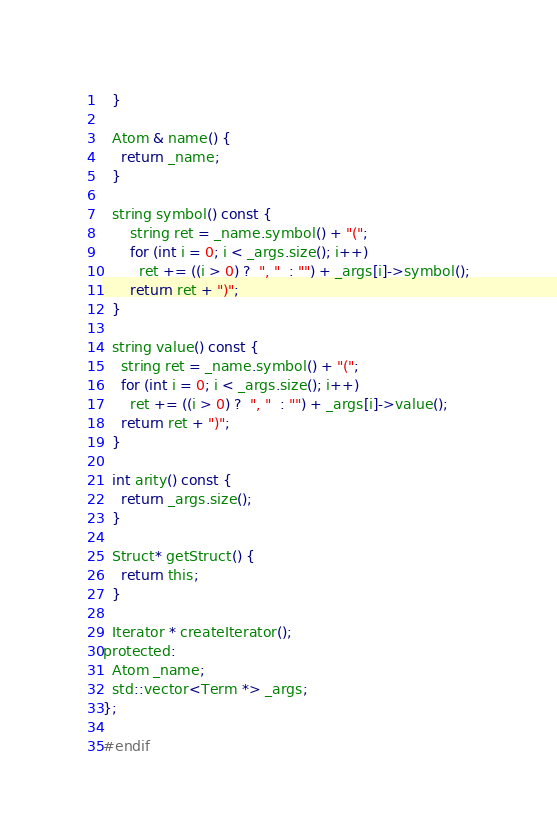Convert code to text. <code><loc_0><loc_0><loc_500><loc_500><_C_>  }

  Atom & name() {
    return _name;
  }

  string symbol() const {
      string ret = _name.symbol() + "(";
      for (int i = 0; i < _args.size(); i++)
        ret += ((i > 0) ?  ", "  : "") + _args[i]->symbol();
      return ret + ")";
  }

  string value() const {
    string ret = _name.symbol() + "(";
    for (int i = 0; i < _args.size(); i++)
      ret += ((i > 0) ?  ", "  : "") + _args[i]->value();
    return ret + ")";
  }

  int arity() const {
    return _args.size();
  }

  Struct* getStruct() {
    return this;
  }

  Iterator * createIterator();
protected:
  Atom _name;
  std::vector<Term *> _args;
};

#endif
</code> 